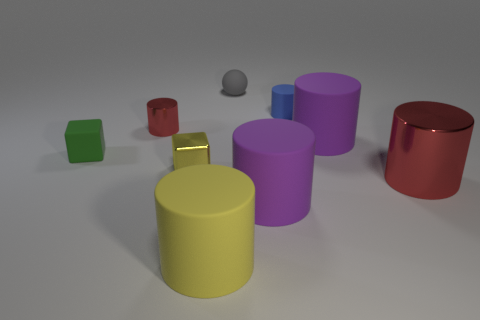Are there any other big shiny objects that have the same shape as the blue thing?
Offer a terse response. Yes. Do the large red cylinder and the red cylinder that is behind the green thing have the same material?
Offer a terse response. Yes. What material is the large purple thing behind the purple thing that is on the left side of the tiny blue cylinder?
Offer a terse response. Rubber. Are there more big purple matte cylinders left of the yellow block than purple matte cylinders?
Make the answer very short. No. Are any tiny purple rubber objects visible?
Ensure brevity in your answer.  No. What is the color of the big rubber cylinder that is behind the big red shiny thing?
Your answer should be compact. Purple. What material is the red cylinder that is the same size as the gray object?
Provide a short and direct response. Metal. What number of other objects are there of the same material as the blue cylinder?
Your response must be concise. 5. There is a metallic object that is on the right side of the small shiny cylinder and left of the big red cylinder; what color is it?
Offer a very short reply. Yellow. What number of objects are matte cylinders that are in front of the tiny blue cylinder or small green rubber objects?
Your response must be concise. 4. 